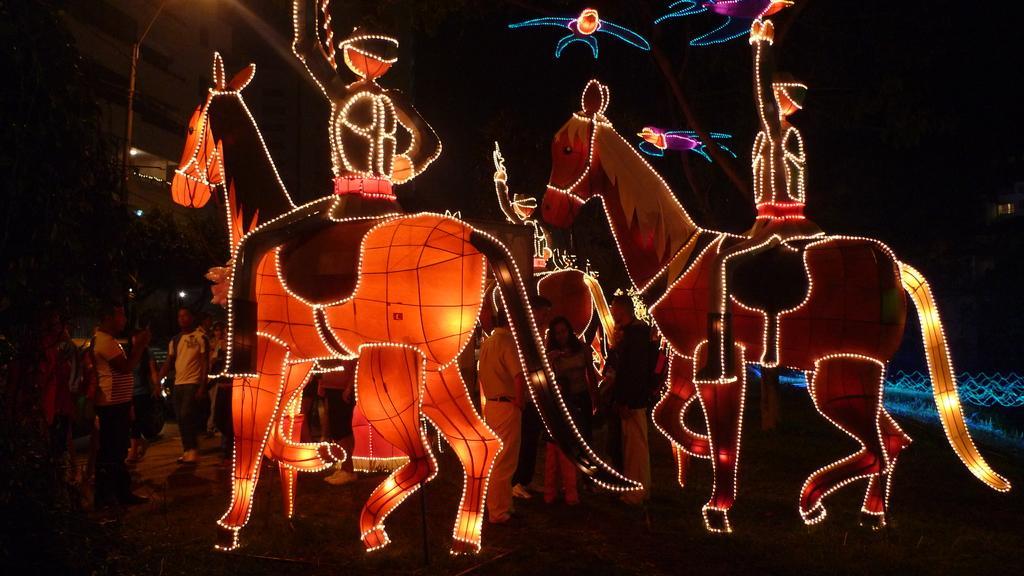In one or two sentences, can you explain what this image depicts? In this picture we can see the cardboard horse and decorated with lights. On the bottom left corner we can see group of person standing near to the building and trees. On the right we can see the grass and fencing. 